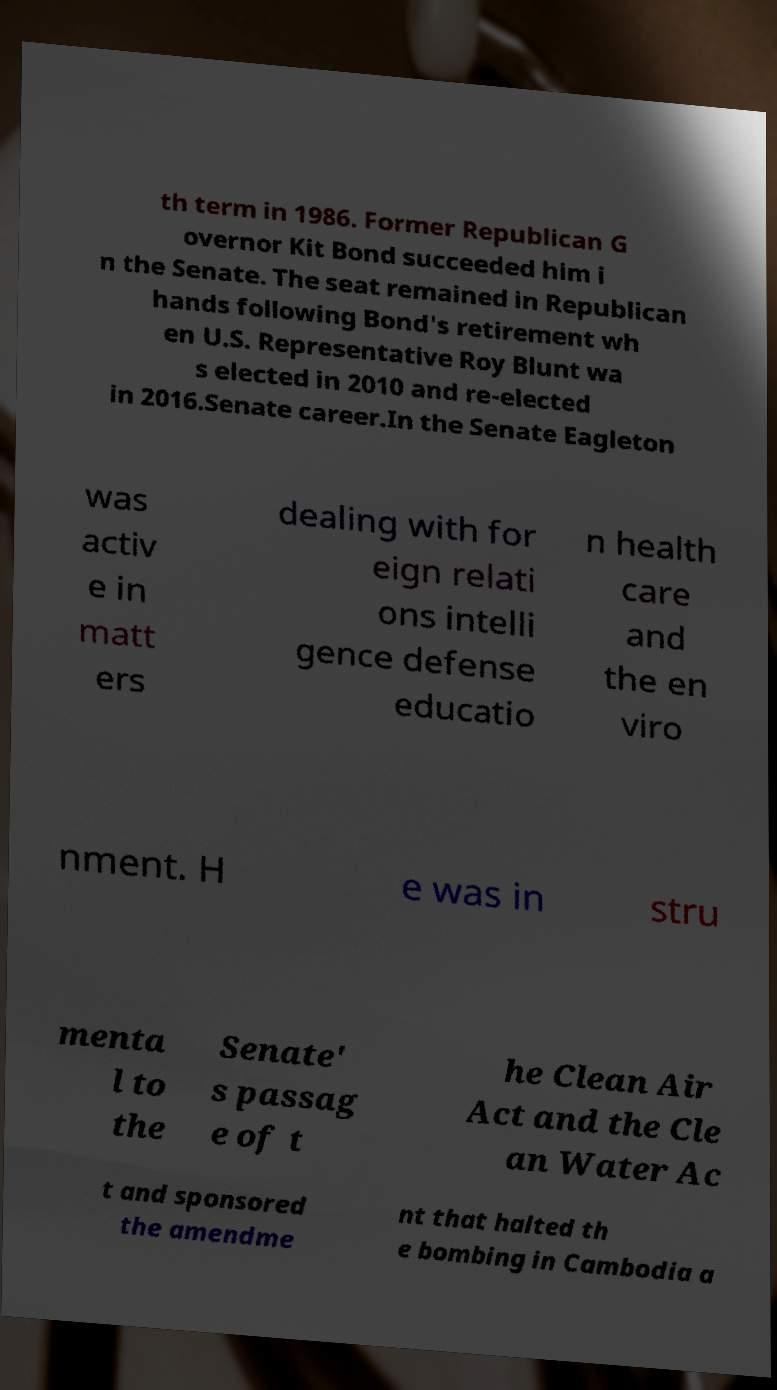For documentation purposes, I need the text within this image transcribed. Could you provide that? th term in 1986. Former Republican G overnor Kit Bond succeeded him i n the Senate. The seat remained in Republican hands following Bond's retirement wh en U.S. Representative Roy Blunt wa s elected in 2010 and re-elected in 2016.Senate career.In the Senate Eagleton was activ e in matt ers dealing with for eign relati ons intelli gence defense educatio n health care and the en viro nment. H e was in stru menta l to the Senate' s passag e of t he Clean Air Act and the Cle an Water Ac t and sponsored the amendme nt that halted th e bombing in Cambodia a 